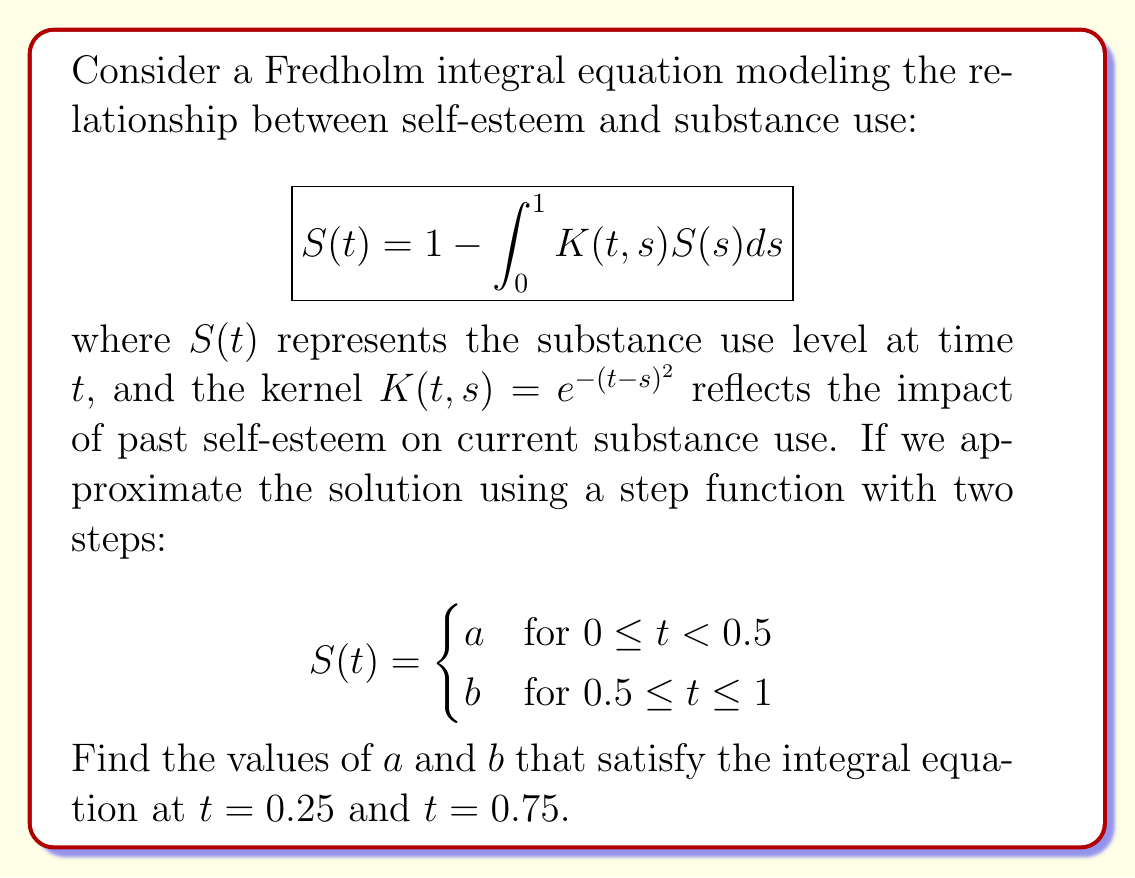Teach me how to tackle this problem. To solve this problem, we'll follow these steps:

1) First, we substitute the step function into the integral equation for $t = 0.25$ and $t = 0.75$.

2) For $t = 0.25$:
   $$a = 1 - \int_0^{0.5} e^{-(0.25-s)^2}a ds - \int_{0.5}^1 e^{-(0.25-s)^2}b ds$$

3) For $t = 0.75$:
   $$b = 1 - \int_0^{0.5} e^{-(0.75-s)^2}a ds - \int_{0.5}^1 e^{-(0.75-s)^2}b ds$$

4) We can evaluate these integrals:
   $$\int_0^{0.5} e^{-(0.25-s)^2} ds \approx 0.4462$$
   $$\int_{0.5}^1 e^{-(0.25-s)^2} ds \approx 0.1942$$
   $$\int_0^{0.5} e^{-(0.75-s)^2} ds \approx 0.1942$$
   $$\int_{0.5}^1 e^{-(0.75-s)^2} ds \approx 0.4462$$

5) Substituting these values:
   $$a = 1 - 0.4462a - 0.1942b$$
   $$b = 1 - 0.1942a - 0.4462b$$

6) We now have a system of two linear equations:
   $$1.4462a + 0.1942b = 1$$
   $$0.1942a + 1.4462b = 1$$

7) Solving this system (e.g., using substitution or matrix methods):
   $$a \approx 0.6648$$
   $$b \approx 0.6648$$

Therefore, the solution to the integral equation, when approximated by a two-step function, has equal values for both steps.
Answer: $a \approx 0.6648, b \approx 0.6648$ 